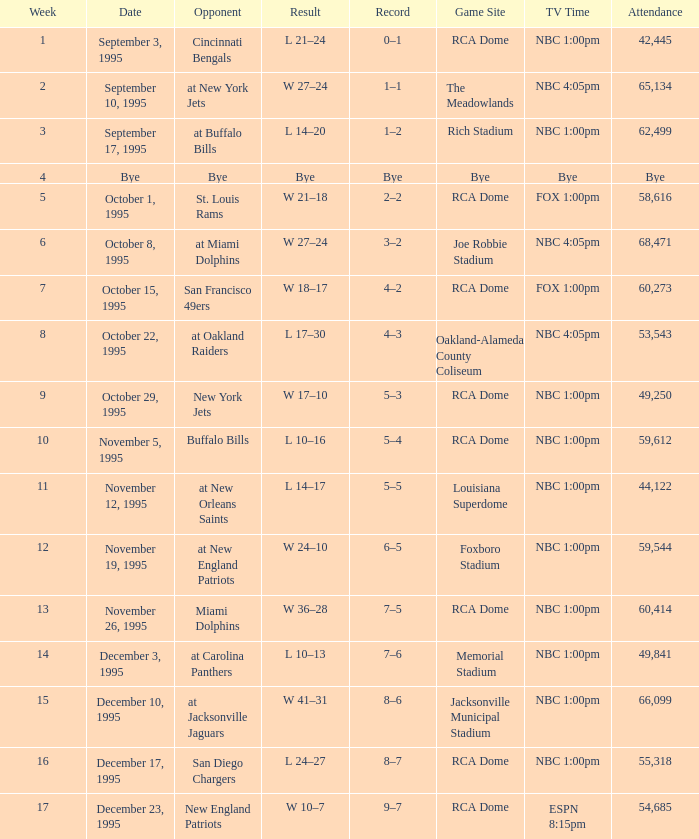Which game site features a match against the san diego chargers' opponent? RCA Dome. 